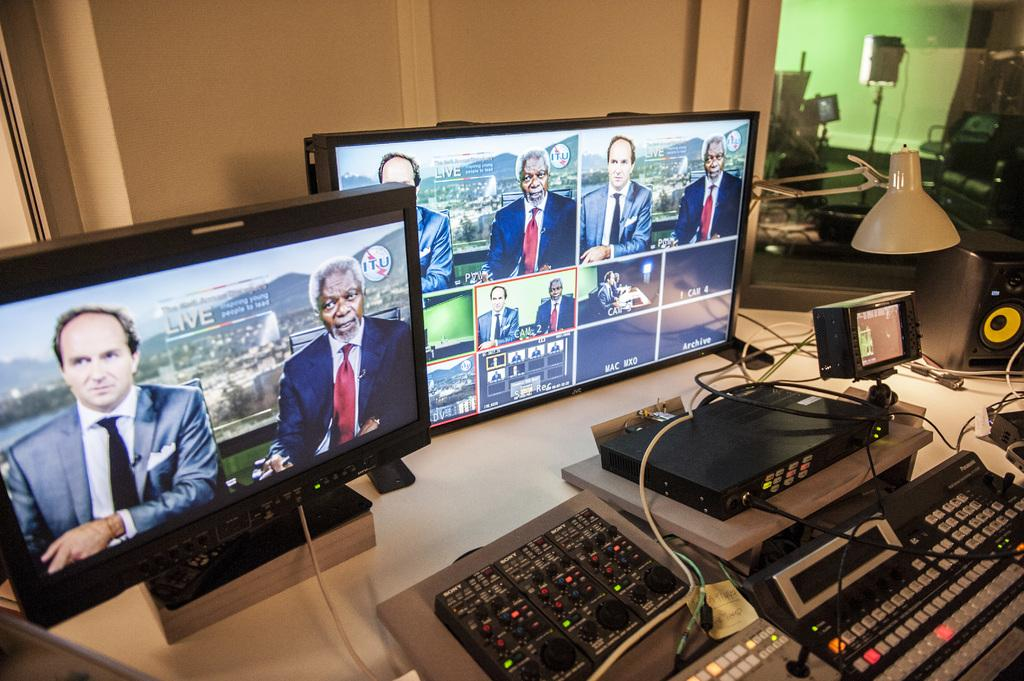<image>
Describe the image concisely. Two screens showing views of a live television broadcast. 